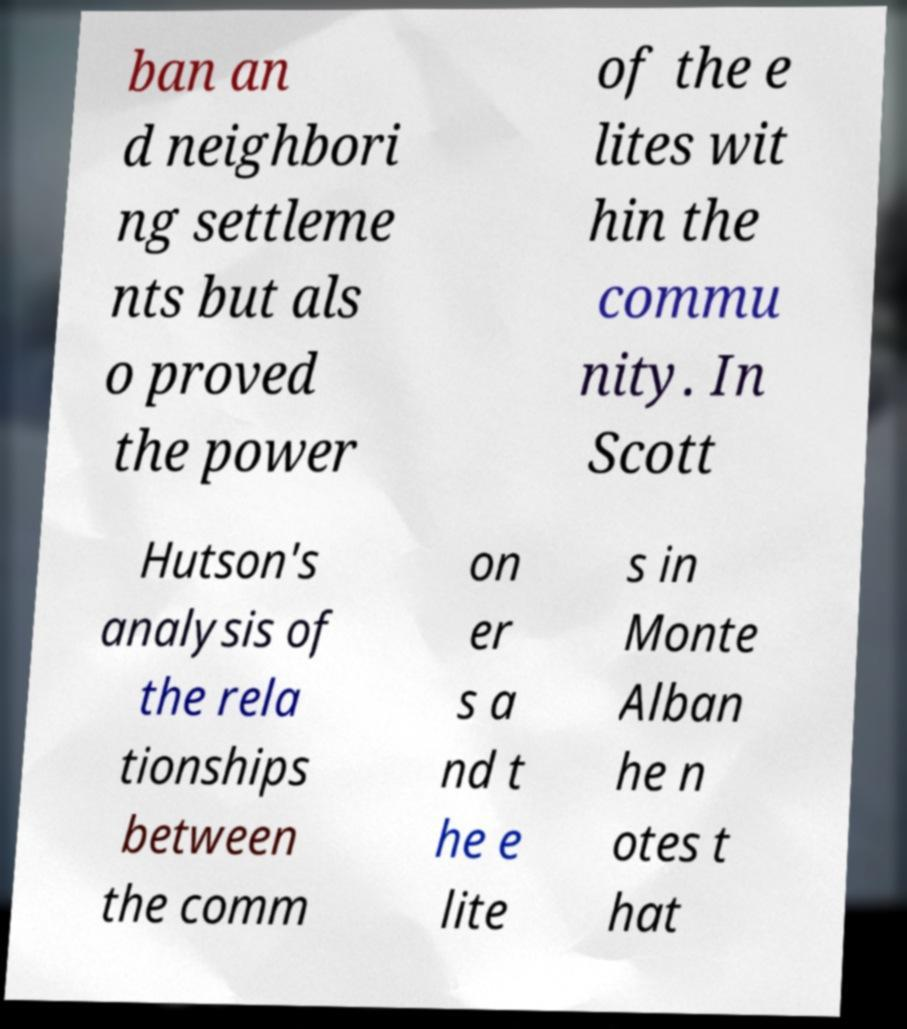I need the written content from this picture converted into text. Can you do that? ban an d neighbori ng settleme nts but als o proved the power of the e lites wit hin the commu nity. In Scott Hutson's analysis of the rela tionships between the comm on er s a nd t he e lite s in Monte Alban he n otes t hat 